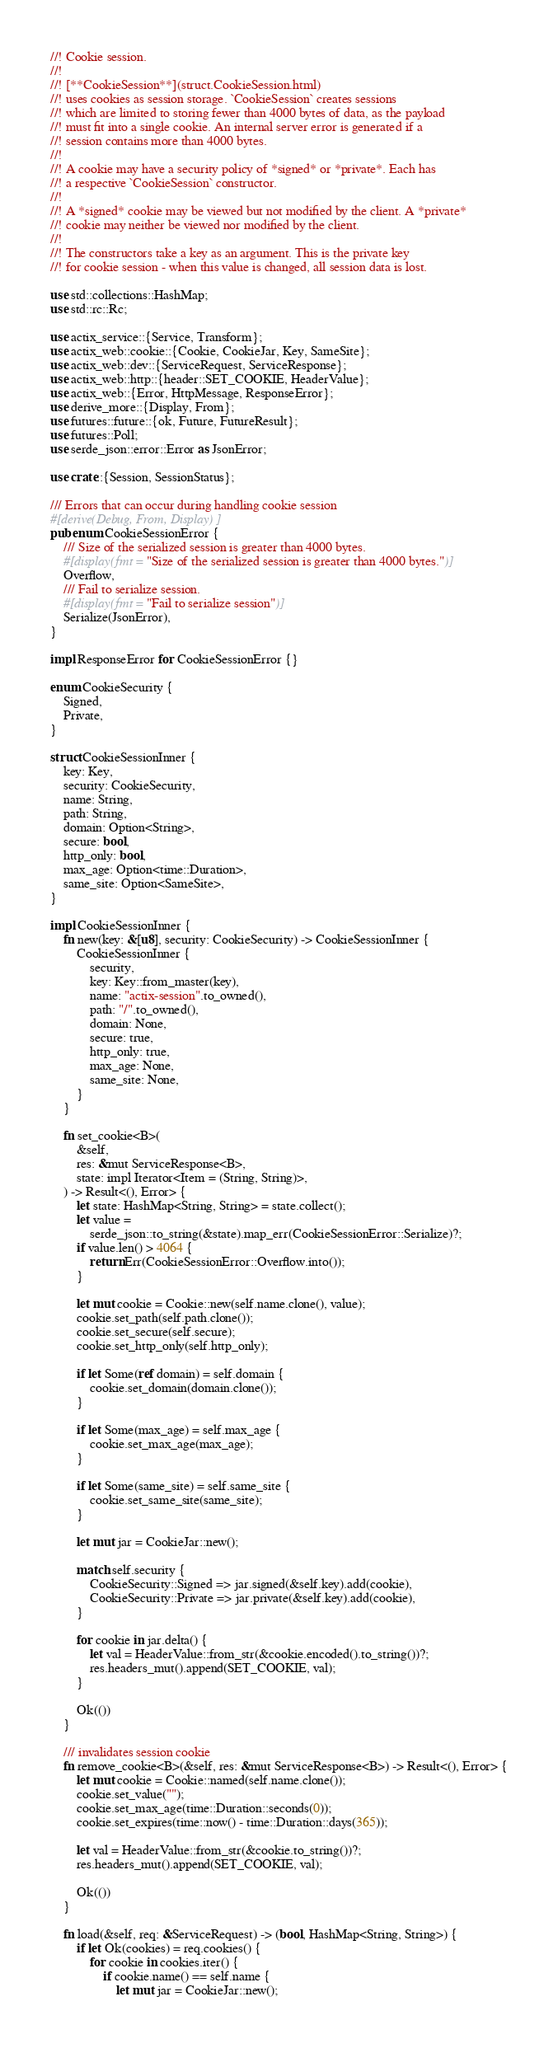Convert code to text. <code><loc_0><loc_0><loc_500><loc_500><_Rust_>//! Cookie session.
//!
//! [**CookieSession**](struct.CookieSession.html)
//! uses cookies as session storage. `CookieSession` creates sessions
//! which are limited to storing fewer than 4000 bytes of data, as the payload
//! must fit into a single cookie. An internal server error is generated if a
//! session contains more than 4000 bytes.
//!
//! A cookie may have a security policy of *signed* or *private*. Each has
//! a respective `CookieSession` constructor.
//!
//! A *signed* cookie may be viewed but not modified by the client. A *private*
//! cookie may neither be viewed nor modified by the client.
//!
//! The constructors take a key as an argument. This is the private key
//! for cookie session - when this value is changed, all session data is lost.

use std::collections::HashMap;
use std::rc::Rc;

use actix_service::{Service, Transform};
use actix_web::cookie::{Cookie, CookieJar, Key, SameSite};
use actix_web::dev::{ServiceRequest, ServiceResponse};
use actix_web::http::{header::SET_COOKIE, HeaderValue};
use actix_web::{Error, HttpMessage, ResponseError};
use derive_more::{Display, From};
use futures::future::{ok, Future, FutureResult};
use futures::Poll;
use serde_json::error::Error as JsonError;

use crate::{Session, SessionStatus};

/// Errors that can occur during handling cookie session
#[derive(Debug, From, Display)]
pub enum CookieSessionError {
    /// Size of the serialized session is greater than 4000 bytes.
    #[display(fmt = "Size of the serialized session is greater than 4000 bytes.")]
    Overflow,
    /// Fail to serialize session.
    #[display(fmt = "Fail to serialize session")]
    Serialize(JsonError),
}

impl ResponseError for CookieSessionError {}

enum CookieSecurity {
    Signed,
    Private,
}

struct CookieSessionInner {
    key: Key,
    security: CookieSecurity,
    name: String,
    path: String,
    domain: Option<String>,
    secure: bool,
    http_only: bool,
    max_age: Option<time::Duration>,
    same_site: Option<SameSite>,
}

impl CookieSessionInner {
    fn new(key: &[u8], security: CookieSecurity) -> CookieSessionInner {
        CookieSessionInner {
            security,
            key: Key::from_master(key),
            name: "actix-session".to_owned(),
            path: "/".to_owned(),
            domain: None,
            secure: true,
            http_only: true,
            max_age: None,
            same_site: None,
        }
    }

    fn set_cookie<B>(
        &self,
        res: &mut ServiceResponse<B>,
        state: impl Iterator<Item = (String, String)>,
    ) -> Result<(), Error> {
        let state: HashMap<String, String> = state.collect();
        let value =
            serde_json::to_string(&state).map_err(CookieSessionError::Serialize)?;
        if value.len() > 4064 {
            return Err(CookieSessionError::Overflow.into());
        }

        let mut cookie = Cookie::new(self.name.clone(), value);
        cookie.set_path(self.path.clone());
        cookie.set_secure(self.secure);
        cookie.set_http_only(self.http_only);

        if let Some(ref domain) = self.domain {
            cookie.set_domain(domain.clone());
        }

        if let Some(max_age) = self.max_age {
            cookie.set_max_age(max_age);
        }

        if let Some(same_site) = self.same_site {
            cookie.set_same_site(same_site);
        }

        let mut jar = CookieJar::new();

        match self.security {
            CookieSecurity::Signed => jar.signed(&self.key).add(cookie),
            CookieSecurity::Private => jar.private(&self.key).add(cookie),
        }

        for cookie in jar.delta() {
            let val = HeaderValue::from_str(&cookie.encoded().to_string())?;
            res.headers_mut().append(SET_COOKIE, val);
        }

        Ok(())
    }

    /// invalidates session cookie
    fn remove_cookie<B>(&self, res: &mut ServiceResponse<B>) -> Result<(), Error> {
        let mut cookie = Cookie::named(self.name.clone());
        cookie.set_value("");
        cookie.set_max_age(time::Duration::seconds(0));
        cookie.set_expires(time::now() - time::Duration::days(365));

        let val = HeaderValue::from_str(&cookie.to_string())?;
        res.headers_mut().append(SET_COOKIE, val);

        Ok(())
    }

    fn load(&self, req: &ServiceRequest) -> (bool, HashMap<String, String>) {
        if let Ok(cookies) = req.cookies() {
            for cookie in cookies.iter() {
                if cookie.name() == self.name {
                    let mut jar = CookieJar::new();</code> 